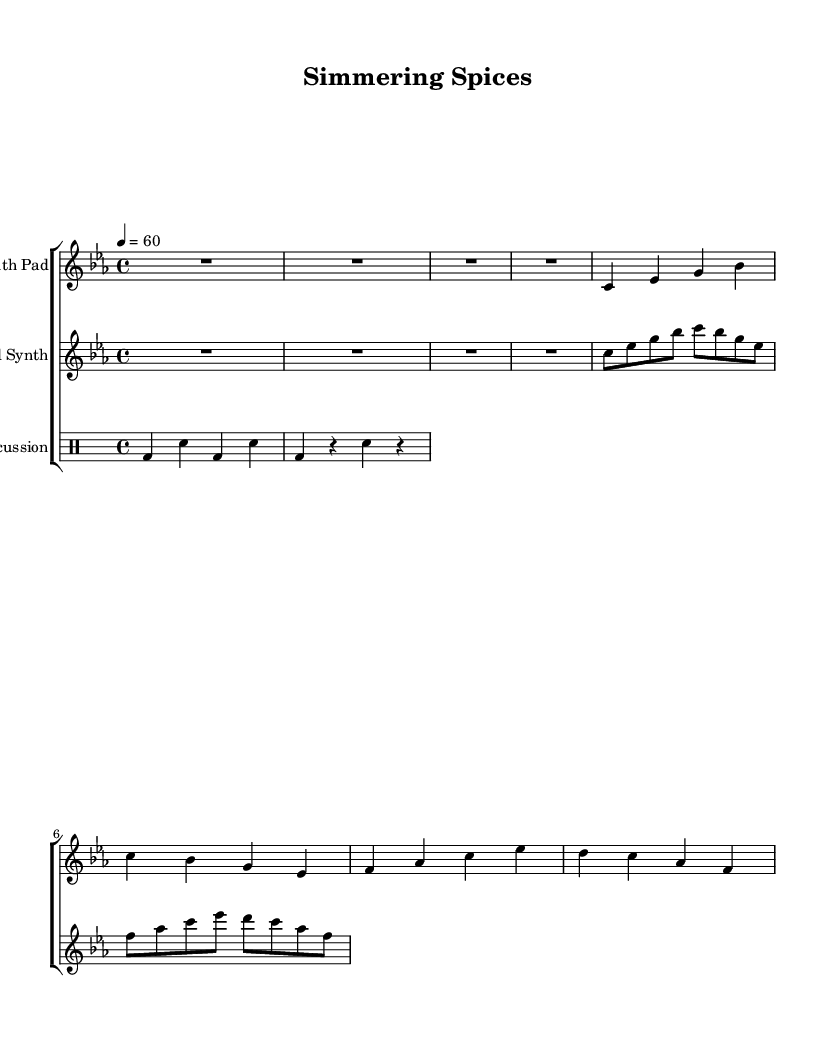What is the key signature of this music? The key signature is C minor, which has three flats: B-flat, E-flat, and A-flat. This is identifiable from the key signature at the beginning of the staff.
Answer: C minor What is the time signature of this music? The time signature is 4/4, indicating that there are four beats per measure and a quarter note receives one beat. This can be seen at the beginning of the sheet music where the time signature is notated.
Answer: 4/4 What is the tempo marking? The tempo marking is 60 beats per minute, indicated in the score by '4 = 60'. This tells the performer the speed at which to play the piece.
Answer: 60 How many measures are in the synth pad part? The synth pad part consists of five measures, as determined by counting all the vertical lines (bar lines) in the music. Each measure is separated by these lines.
Answer: 5 What instrument is indicated for the synth pad? The instrument indicated for the synth pad is simply referred to as "Synth Pad" at the beginning of that part in the score. This establishes the specific sound or timbre expected for this section.
Answer: Synth Pad What type of synthesizer sound is depicted in the second staff? The second staff is labeled "Plucked Synth," indicating a synthesizer sound that mimics the effect of plucked strings or lighter textures in the electronic music genre. This is explicitly mentioned in the instrument name notation at the start of that staff.
Answer: Plucked Synth How many beats does the first measure of the percussion part contain? The first measure of the percussion part contains four beats, indicated by 'bd4 sn bd sn'. Each 'bd' (bass drum) and 'sn' (snare drum) represents a beat, and they total to four beats.
Answer: 4 